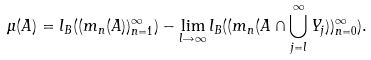Convert formula to latex. <formula><loc_0><loc_0><loc_500><loc_500>\mu ( A ) = l _ { B } ( ( m _ { n } ( A ) ) _ { n = 1 } ^ { \infty } ) - \lim _ { l \rightarrow \infty } l _ { B } ( ( m _ { n } ( A \cap \bigcup _ { j = l } ^ { \infty } Y _ { j } ) ) _ { n = 0 } ^ { \infty } ) .</formula> 